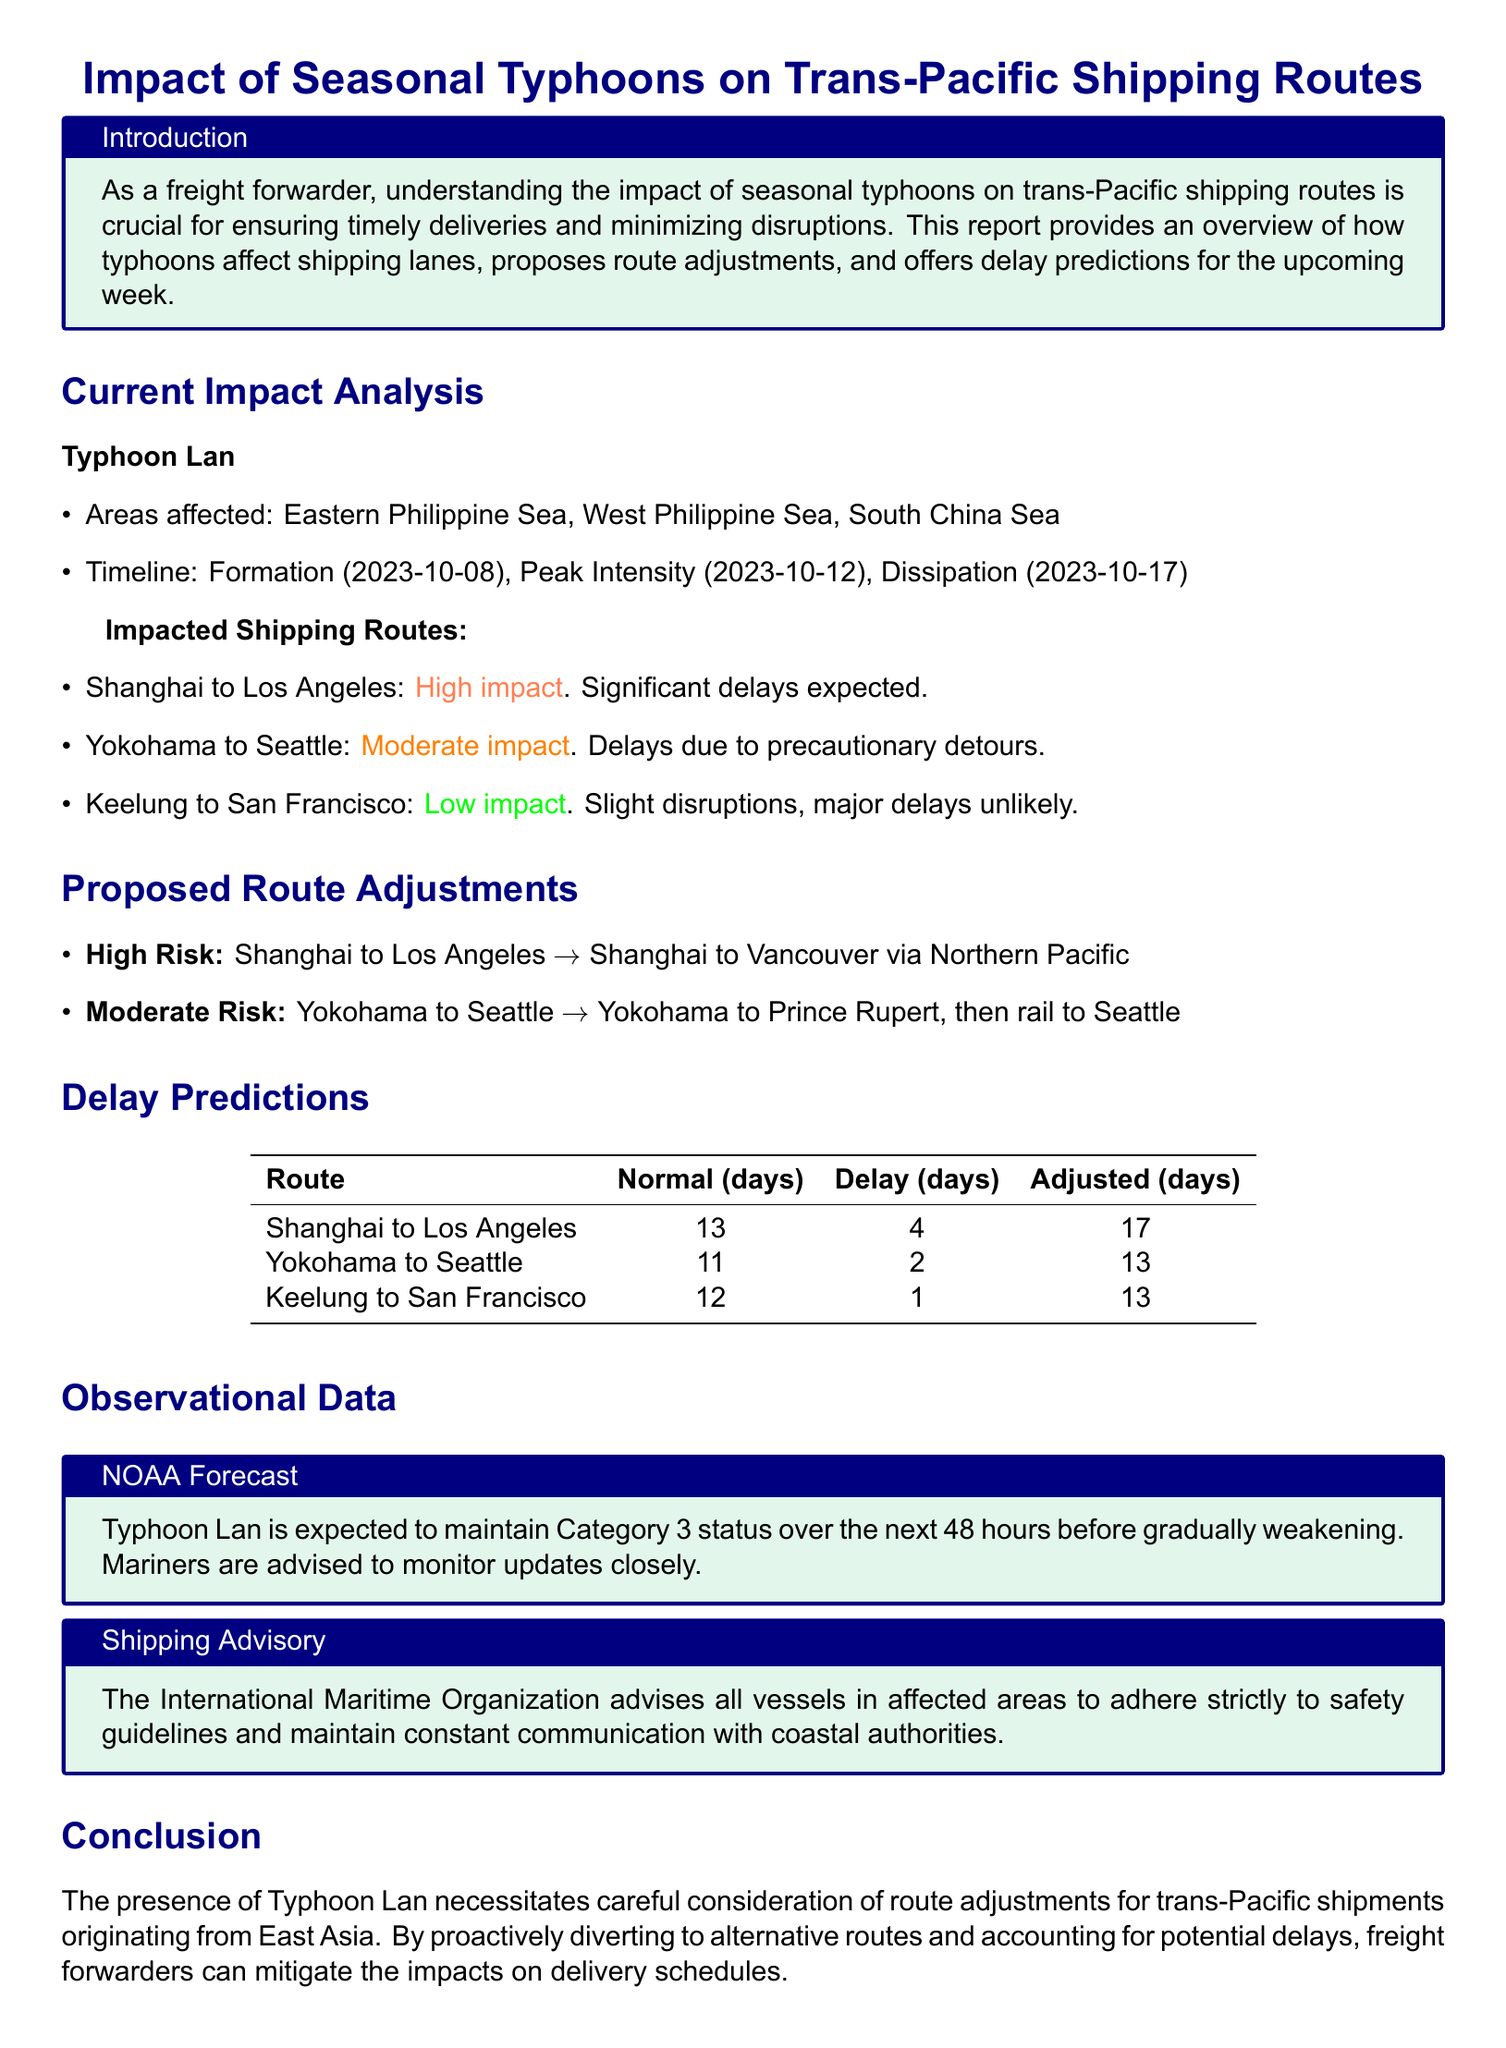What is the formation date of Typhoon Lan? The document states that Typhoon Lan formed on October 8, 2023.
Answer: October 8, 2023 What is the peak intensity date of Typhoon Lan? The document mentions that the peak intensity occurred on October 12, 2023.
Answer: October 12, 2023 Which route has a high impact due to Typhoon Lan? The document identifies the Shanghai to Los Angeles route as having a high impact with significant delays expected.
Answer: Shanghai to Los Angeles What is the expected delay for the Yokohama to Seattle route? The document states that the expected delay for this route is 2 days.
Answer: 2 days What is the adjusted travel time for the Shanghai to Los Angeles route? The document specifies that the adjusted travel time for this route is 17 days.
Answer: 17 days What alternative route is proposed for high-risk shipments from Shanghai to Los Angeles? The proposed alternative route for high-risk shipments is from Shanghai to Vancouver via Northern Pacific.
Answer: Shanghai to Vancouver via Northern Pacific What category is Typhoon Lan expected to maintain? The NOAA forecast indicates that Typhoon Lan is expected to maintain Category 3 status.
Answer: Category 3 What safety measures does the International Maritime Organization advise? The advisory states that all vessels in affected areas should adhere strictly to safety guidelines.
Answer: Safety guidelines How many days of normal travel time does the Keelung to San Francisco route have? The document lists the normal travel time for this route as 12 days.
Answer: 12 days 